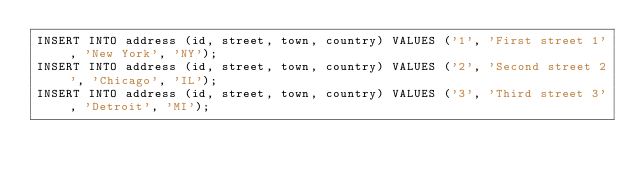Convert code to text. <code><loc_0><loc_0><loc_500><loc_500><_SQL_>INSERT INTO address (id, street, town, country) VALUES ('1', 'First street 1', 'New York', 'NY');
INSERT INTO address (id, street, town, country) VALUES ('2', 'Second street 2', 'Chicago', 'IL');
INSERT INTO address (id, street, town, country) VALUES ('3', 'Third street 3', 'Detroit', 'MI');</code> 